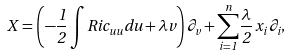Convert formula to latex. <formula><loc_0><loc_0><loc_500><loc_500>X = \left ( - \frac { 1 } { 2 } \int R i c _ { u u } d u + \lambda v \right ) \partial _ { v } + \underset { i = 1 } { \overset { n } { \sum } } \frac { \lambda } { 2 } \, x _ { i } \, \partial _ { i } ,</formula> 